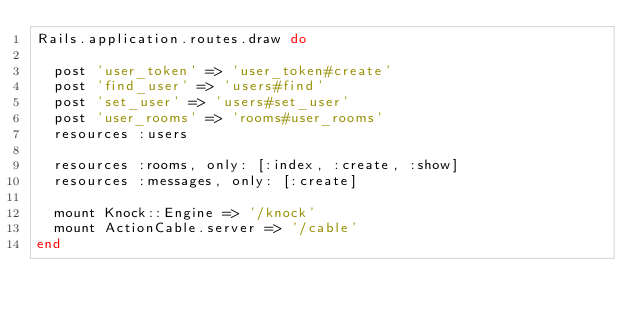Convert code to text. <code><loc_0><loc_0><loc_500><loc_500><_Ruby_>Rails.application.routes.draw do

  post 'user_token' => 'user_token#create'
  post 'find_user' => 'users#find'
  post 'set_user' => 'users#set_user'
  post 'user_rooms' => 'rooms#user_rooms'
  resources :users

  resources :rooms, only: [:index, :create, :show]
  resources :messages, only: [:create]

  mount Knock::Engine => '/knock'
  mount ActionCable.server => '/cable'
end
</code> 